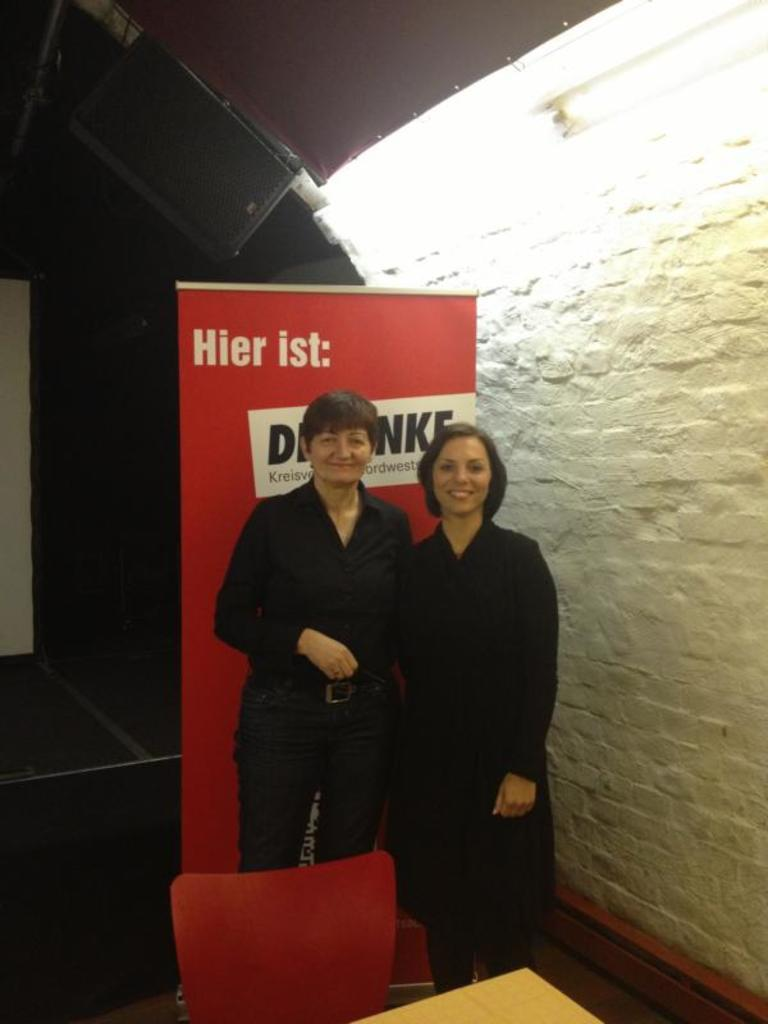How many women are in the image? There are two women in the image. What are the women doing in the image? The women are standing behind a chair. What is in front of the chair? There is a table in front of the chair. What can be seen in the background of the image? There is a wall light and a poster in the background. What type of curve can be seen on the club in the image? There is no club present in the image, and therefore no curve can be observed. 